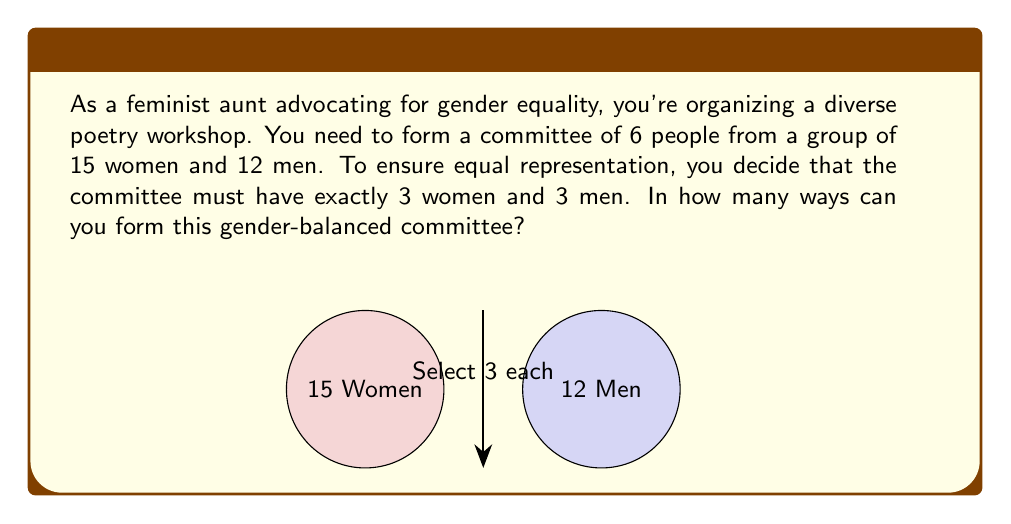Provide a solution to this math problem. Let's approach this step-by-step:

1) We need to select 3 women out of 15 and 3 men out of 12.

2) For the women:
   We can calculate this using the combination formula:
   $$\binom{15}{3} = \frac{15!}{3!(15-3)!} = \frac{15!}{3!12!}$$

3) For the men:
   Similarly, we use the combination formula:
   $$\binom{12}{3} = \frac{12!}{3!(12-3)!} = \frac{12!}{3!9!}$$

4) According to the multiplication principle, the total number of ways to form the committee is the product of these two combinations:

   $$\binom{15}{3} \times \binom{12}{3}$$

5) Let's calculate each part:
   $$\binom{15}{3} = \frac{15 \times 14 \times 13}{3 \times 2 \times 1} = 455$$
   $$\binom{12}{3} = \frac{12 \times 11 \times 10}{3 \times 2 \times 1} = 220$$

6) Now, we multiply these results:
   $$455 \times 220 = 100,100$$

Therefore, there are 100,100 ways to form this gender-balanced committee.
Answer: 100,100 